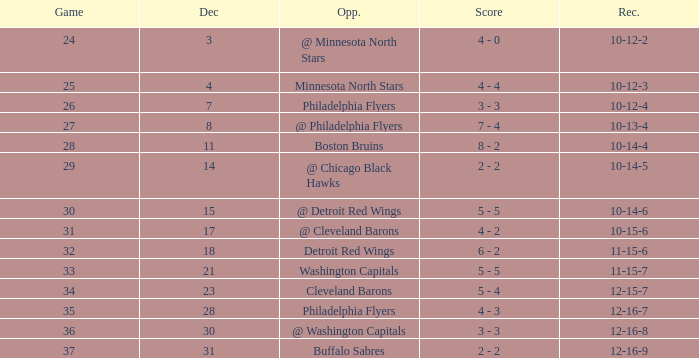What is the lowest December, when Score is "4 - 4"? 4.0. 